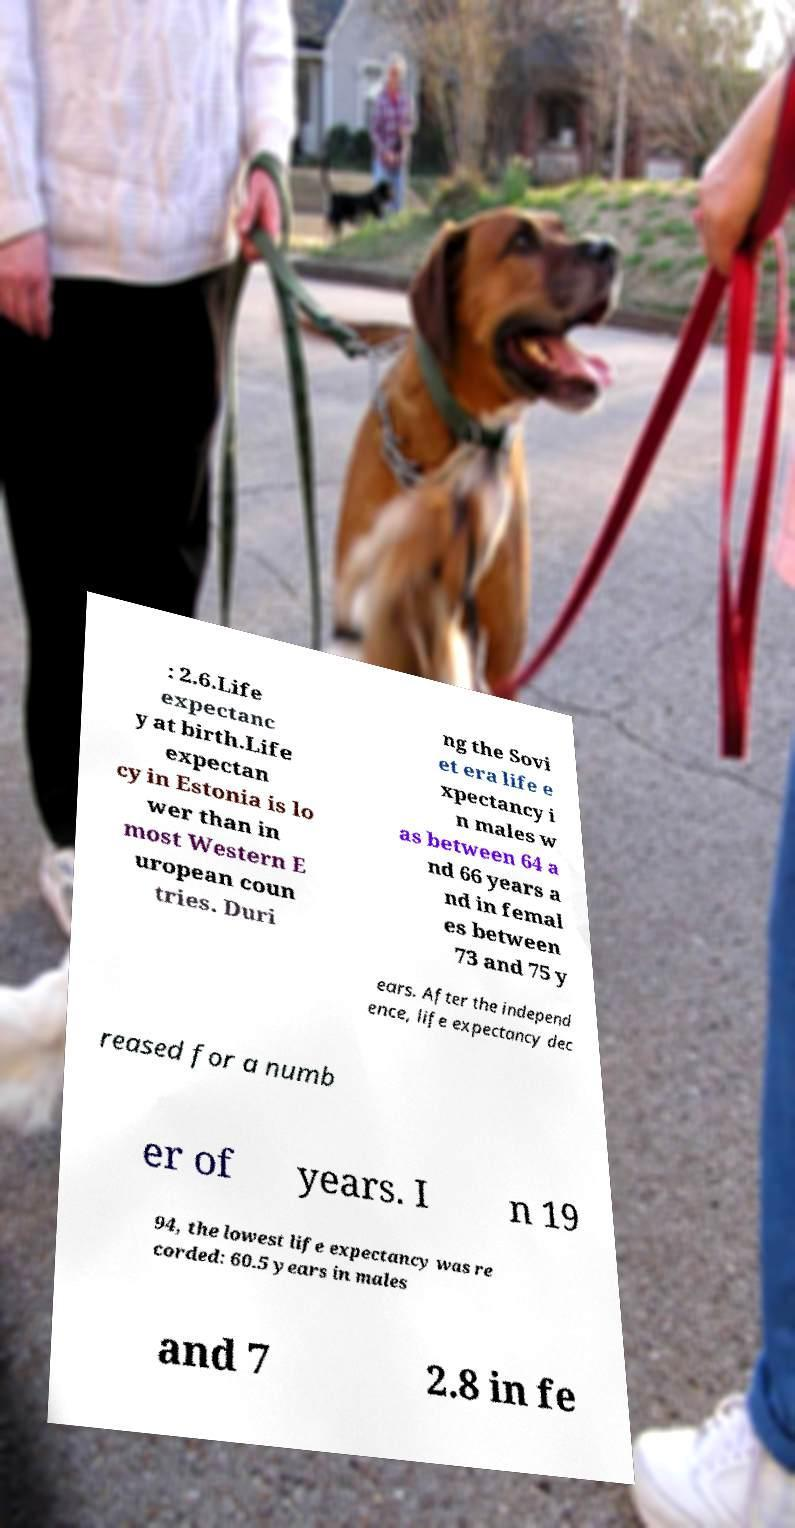For documentation purposes, I need the text within this image transcribed. Could you provide that? : 2.6.Life expectanc y at birth.Life expectan cy in Estonia is lo wer than in most Western E uropean coun tries. Duri ng the Sovi et era life e xpectancy i n males w as between 64 a nd 66 years a nd in femal es between 73 and 75 y ears. After the independ ence, life expectancy dec reased for a numb er of years. I n 19 94, the lowest life expectancy was re corded: 60.5 years in males and 7 2.8 in fe 